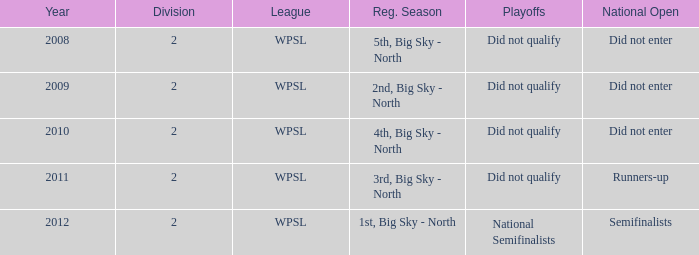What organization was implicated in 2010? WPSL. 